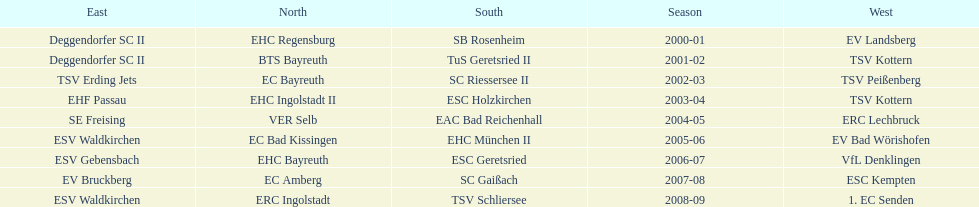Starting with the 2007 - 08 season, does ecs kempten appear in any of the previous years? No. 